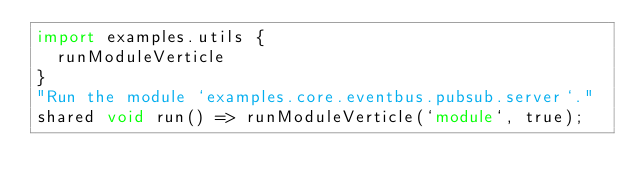Convert code to text. <code><loc_0><loc_0><loc_500><loc_500><_Ceylon_>import examples.utils {
  runModuleVerticle
}
"Run the module `examples.core.eventbus.pubsub.server`."
shared void run() => runModuleVerticle(`module`, true);
</code> 